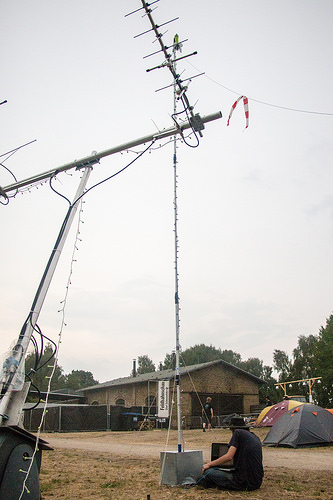<image>
Is there a hat on the shirt? No. The hat is not positioned on the shirt. They may be near each other, but the hat is not supported by or resting on top of the shirt. 